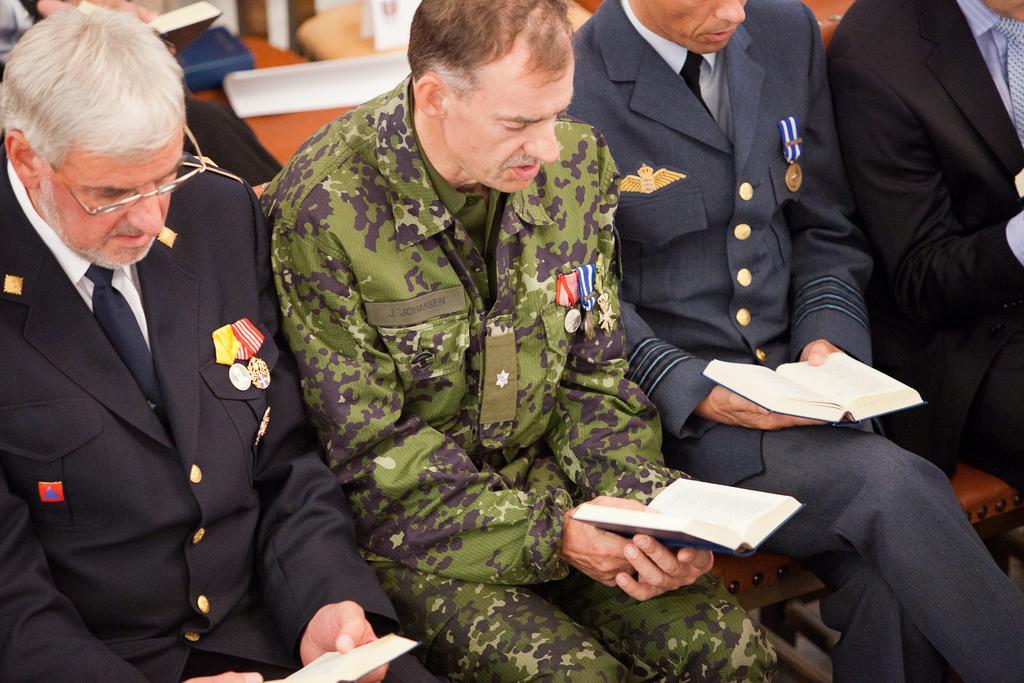Describe this image in one or two sentences. In this picture, we see four men are sitting on the bench. Three of them are holding books in their hands. Behind them, we see a man is sitting on the bench. Beside him, we see a blue bag and papers are placed on the brown bench. In the background, it is blurred. 